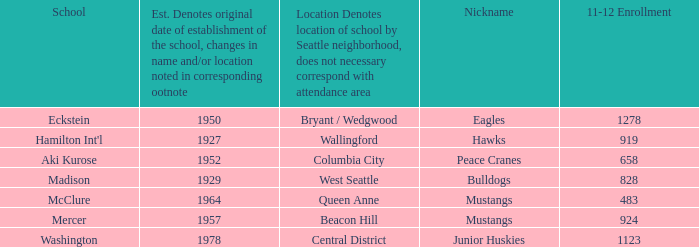Name the location for school eckstein Bryant / Wedgwood. 